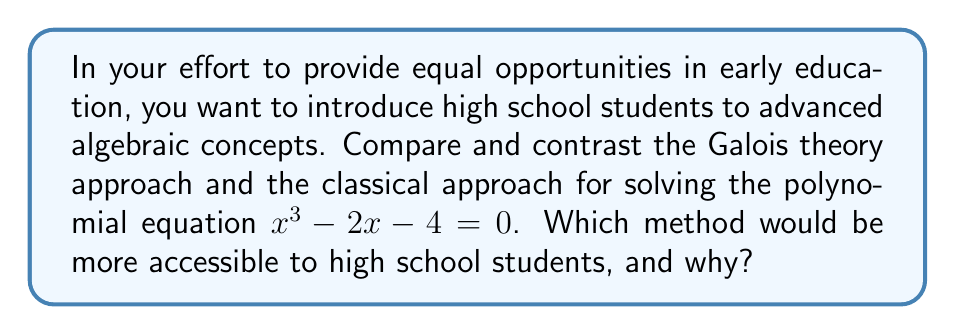Teach me how to tackle this problem. Let's compare the two approaches:

1. Classical approach:
   a) First, we can try to factor the polynomial, but it's not easily factorable.
   b) We can use the rational root theorem to check for rational roots:
      Possible rational roots: $\pm 1, \pm 2, \pm 4$
      None of these are roots of the equation.
   c) Since there are no rational roots, we can use the cubic formula:
      For a cubic equation $ax^3 + bx^2 + cx + d = 0$,
      $x = -\frac{1}{3a}(b + C + \frac{\Delta_0}{C})$
      Where $C = \sqrt[3]{\frac{\Delta_1 + \sqrt{\Delta_1^2 - 4\Delta_0^3}}{2}}$
      $\Delta_0 = b^2 - 3ac$
      $\Delta_1 = 2b^3 - 9abc + 27a^2d$

      In our case, $a=1, b=0, c=-2, d=-4$
      This leads to a complex solution that's difficult to simplify.

2. Galois theory approach:
   a) Consider the splitting field $K$ of $f(x) = x^3 - 2x - 4$ over $\mathbb{Q}$.
   b) The Galois group $Gal(K/\mathbb{Q})$ is a subgroup of $S_3$.
   c) Since $f(x)$ has no rational roots, $Gal(K/\mathbb{Q}) \cong S_3$ or $A_3$.
   d) The discriminant $\Delta = -4(-2)^3 - 27(-4)^2 = -400$ is not a perfect square.
   e) Therefore, $Gal(K/\mathbb{Q}) \cong S_3$, and $f(x)$ is not solvable by radicals.

For high school students, the classical approach would be more accessible because:
1. It uses concepts they are familiar with (factoring, rational root theorem).
2. It doesn't require advanced group theory knowledge.
3. Even if they can't solve it completely, they can understand the process and limitations.

The Galois theory approach, while more powerful, requires abstract algebra concepts that are typically beyond high school level.
Answer: Classical approach is more accessible for high school students due to familiarity with basic algebraic concepts and not requiring advanced group theory knowledge. 